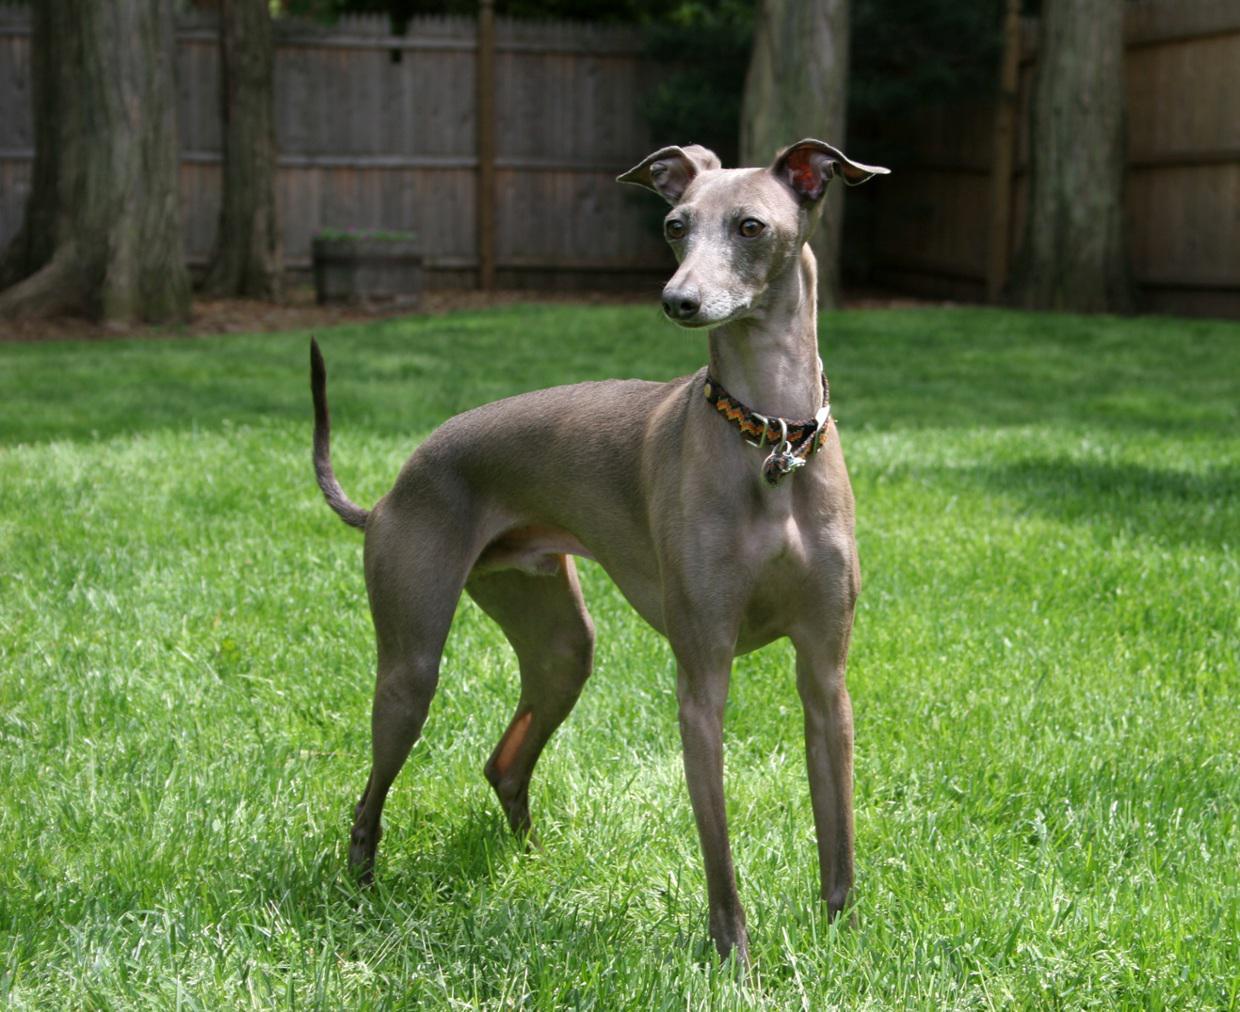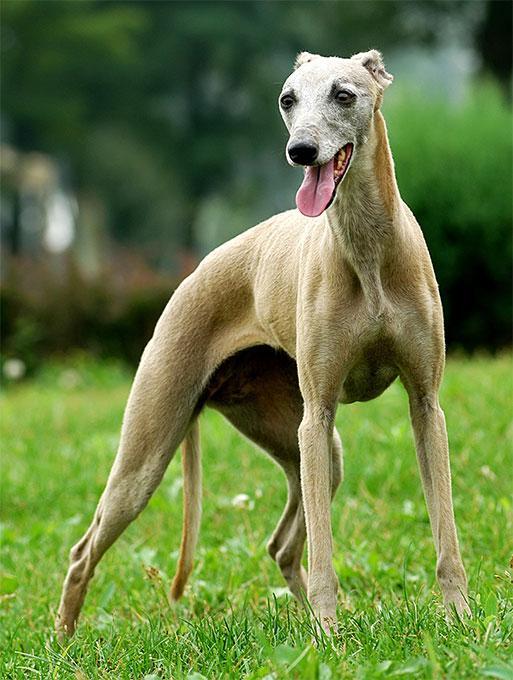The first image is the image on the left, the second image is the image on the right. Given the left and right images, does the statement "There is a dog with its head to the left and its tail to the right." hold true? Answer yes or no. No. 